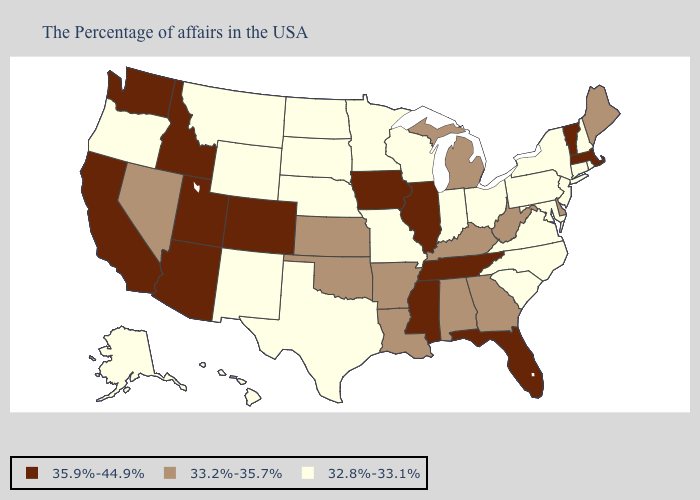Name the states that have a value in the range 32.8%-33.1%?
Concise answer only. Rhode Island, New Hampshire, Connecticut, New York, New Jersey, Maryland, Pennsylvania, Virginia, North Carolina, South Carolina, Ohio, Indiana, Wisconsin, Missouri, Minnesota, Nebraska, Texas, South Dakota, North Dakota, Wyoming, New Mexico, Montana, Oregon, Alaska, Hawaii. What is the lowest value in the MidWest?
Be succinct. 32.8%-33.1%. Among the states that border Arkansas , does Tennessee have the highest value?
Keep it brief. Yes. What is the value of Florida?
Short answer required. 35.9%-44.9%. Name the states that have a value in the range 33.2%-35.7%?
Answer briefly. Maine, Delaware, West Virginia, Georgia, Michigan, Kentucky, Alabama, Louisiana, Arkansas, Kansas, Oklahoma, Nevada. What is the value of Hawaii?
Concise answer only. 32.8%-33.1%. Which states hav the highest value in the South?
Keep it brief. Florida, Tennessee, Mississippi. Which states have the highest value in the USA?
Give a very brief answer. Massachusetts, Vermont, Florida, Tennessee, Illinois, Mississippi, Iowa, Colorado, Utah, Arizona, Idaho, California, Washington. Among the states that border Nevada , which have the highest value?
Keep it brief. Utah, Arizona, Idaho, California. Does Iowa have the highest value in the USA?
Keep it brief. Yes. Name the states that have a value in the range 32.8%-33.1%?
Give a very brief answer. Rhode Island, New Hampshire, Connecticut, New York, New Jersey, Maryland, Pennsylvania, Virginia, North Carolina, South Carolina, Ohio, Indiana, Wisconsin, Missouri, Minnesota, Nebraska, Texas, South Dakota, North Dakota, Wyoming, New Mexico, Montana, Oregon, Alaska, Hawaii. What is the value of Georgia?
Answer briefly. 33.2%-35.7%. What is the value of North Carolina?
Concise answer only. 32.8%-33.1%. Does the map have missing data?
Concise answer only. No. Which states have the lowest value in the Northeast?
Keep it brief. Rhode Island, New Hampshire, Connecticut, New York, New Jersey, Pennsylvania. 